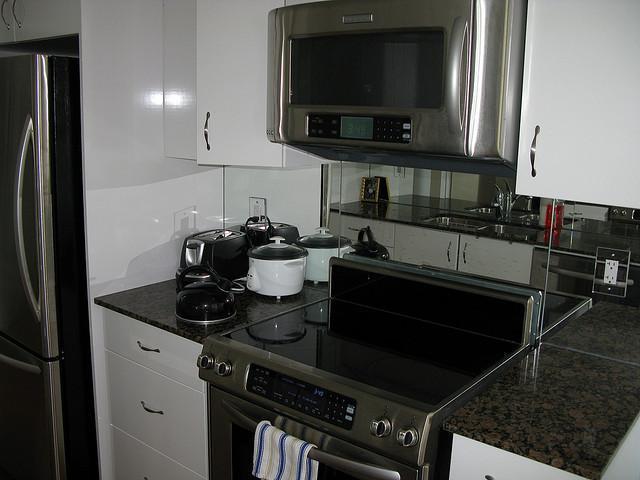How many towels are hanging?
Give a very brief answer. 1. How many burners are on the stove?
Give a very brief answer. 4. How many giraffe are there?
Give a very brief answer. 0. 